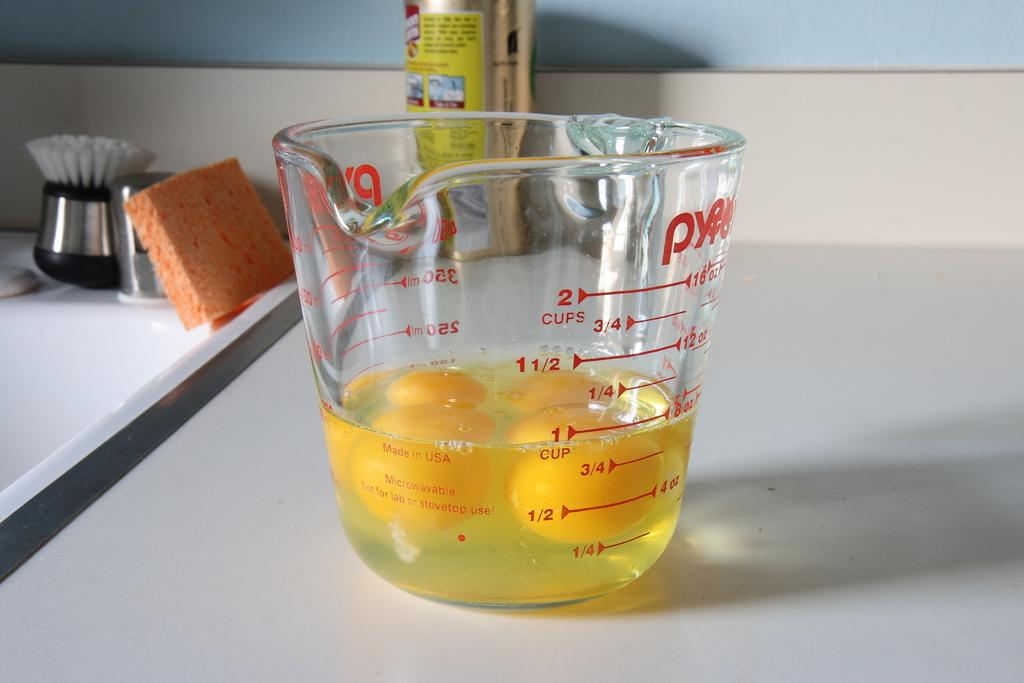<image>
Write a terse but informative summary of the picture. A glass measuring cup is filled with eggs to the one cup line. 